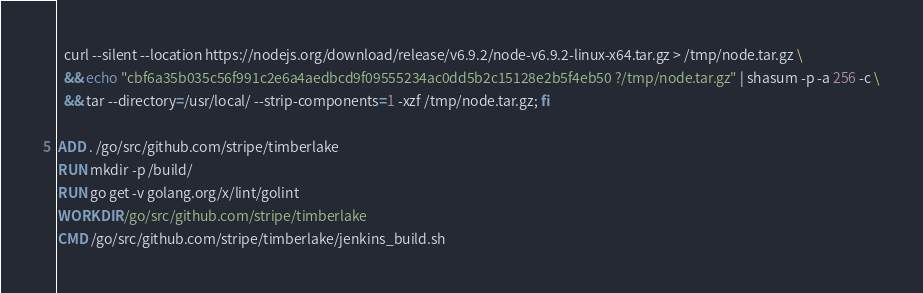<code> <loc_0><loc_0><loc_500><loc_500><_Dockerfile_>  curl --silent --location https://nodejs.org/download/release/v6.9.2/node-v6.9.2-linux-x64.tar.gz > /tmp/node.tar.gz \
  && echo "cbf6a35b035c56f991c2e6a4aedbcd9f09555234ac0dd5b2c15128e2b5f4eb50 ?/tmp/node.tar.gz" | shasum -p -a 256 -c \
  && tar --directory=/usr/local/ --strip-components=1 -xzf /tmp/node.tar.gz; fi

ADD . /go/src/github.com/stripe/timberlake
RUN mkdir -p /build/
RUN go get -v golang.org/x/lint/golint
WORKDIR /go/src/github.com/stripe/timberlake
CMD /go/src/github.com/stripe/timberlake/jenkins_build.sh
</code> 